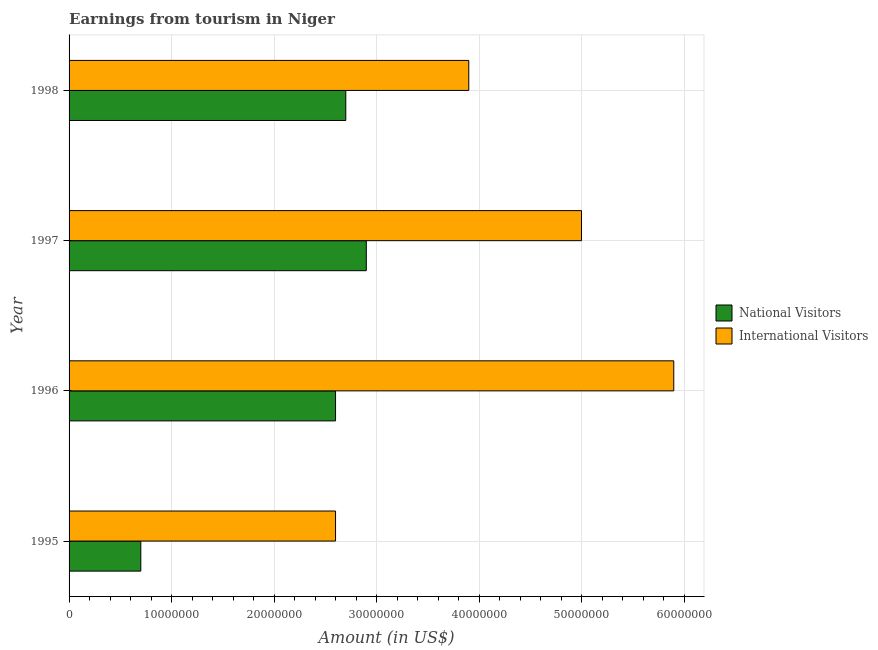How many groups of bars are there?
Give a very brief answer. 4. Are the number of bars per tick equal to the number of legend labels?
Your response must be concise. Yes. In how many cases, is the number of bars for a given year not equal to the number of legend labels?
Give a very brief answer. 0. What is the amount earned from international visitors in 1997?
Your answer should be very brief. 5.00e+07. Across all years, what is the maximum amount earned from international visitors?
Ensure brevity in your answer.  5.90e+07. Across all years, what is the minimum amount earned from national visitors?
Ensure brevity in your answer.  7.00e+06. In which year was the amount earned from national visitors maximum?
Offer a very short reply. 1997. In which year was the amount earned from international visitors minimum?
Offer a very short reply. 1995. What is the total amount earned from international visitors in the graph?
Your answer should be compact. 1.74e+08. What is the difference between the amount earned from national visitors in 1997 and that in 1998?
Provide a short and direct response. 2.00e+06. What is the difference between the amount earned from international visitors in 1995 and the amount earned from national visitors in 1998?
Your answer should be compact. -1.00e+06. What is the average amount earned from international visitors per year?
Your answer should be very brief. 4.35e+07. In the year 1995, what is the difference between the amount earned from international visitors and amount earned from national visitors?
Give a very brief answer. 1.90e+07. In how many years, is the amount earned from national visitors greater than 36000000 US$?
Your answer should be very brief. 0. What is the ratio of the amount earned from national visitors in 1995 to that in 1997?
Provide a succinct answer. 0.24. Is the difference between the amount earned from national visitors in 1996 and 1998 greater than the difference between the amount earned from international visitors in 1996 and 1998?
Offer a very short reply. No. What is the difference between the highest and the lowest amount earned from international visitors?
Your response must be concise. 3.30e+07. In how many years, is the amount earned from national visitors greater than the average amount earned from national visitors taken over all years?
Provide a short and direct response. 3. What does the 1st bar from the top in 1996 represents?
Provide a succinct answer. International Visitors. What does the 2nd bar from the bottom in 1995 represents?
Make the answer very short. International Visitors. How many bars are there?
Your answer should be very brief. 8. How many years are there in the graph?
Give a very brief answer. 4. Does the graph contain grids?
Your response must be concise. Yes. How are the legend labels stacked?
Offer a terse response. Vertical. What is the title of the graph?
Your answer should be very brief. Earnings from tourism in Niger. What is the label or title of the X-axis?
Provide a succinct answer. Amount (in US$). What is the label or title of the Y-axis?
Provide a short and direct response. Year. What is the Amount (in US$) of National Visitors in 1995?
Offer a terse response. 7.00e+06. What is the Amount (in US$) in International Visitors in 1995?
Offer a very short reply. 2.60e+07. What is the Amount (in US$) in National Visitors in 1996?
Offer a very short reply. 2.60e+07. What is the Amount (in US$) of International Visitors in 1996?
Your response must be concise. 5.90e+07. What is the Amount (in US$) in National Visitors in 1997?
Your answer should be compact. 2.90e+07. What is the Amount (in US$) in International Visitors in 1997?
Make the answer very short. 5.00e+07. What is the Amount (in US$) of National Visitors in 1998?
Offer a terse response. 2.70e+07. What is the Amount (in US$) of International Visitors in 1998?
Provide a succinct answer. 3.90e+07. Across all years, what is the maximum Amount (in US$) of National Visitors?
Offer a terse response. 2.90e+07. Across all years, what is the maximum Amount (in US$) in International Visitors?
Your answer should be very brief. 5.90e+07. Across all years, what is the minimum Amount (in US$) of International Visitors?
Provide a short and direct response. 2.60e+07. What is the total Amount (in US$) of National Visitors in the graph?
Give a very brief answer. 8.90e+07. What is the total Amount (in US$) in International Visitors in the graph?
Give a very brief answer. 1.74e+08. What is the difference between the Amount (in US$) in National Visitors in 1995 and that in 1996?
Provide a short and direct response. -1.90e+07. What is the difference between the Amount (in US$) in International Visitors in 1995 and that in 1996?
Provide a succinct answer. -3.30e+07. What is the difference between the Amount (in US$) of National Visitors in 1995 and that in 1997?
Offer a terse response. -2.20e+07. What is the difference between the Amount (in US$) in International Visitors in 1995 and that in 1997?
Your response must be concise. -2.40e+07. What is the difference between the Amount (in US$) in National Visitors in 1995 and that in 1998?
Offer a terse response. -2.00e+07. What is the difference between the Amount (in US$) in International Visitors in 1995 and that in 1998?
Your answer should be very brief. -1.30e+07. What is the difference between the Amount (in US$) of International Visitors in 1996 and that in 1997?
Your answer should be very brief. 9.00e+06. What is the difference between the Amount (in US$) in National Visitors in 1996 and that in 1998?
Provide a short and direct response. -1.00e+06. What is the difference between the Amount (in US$) in National Visitors in 1997 and that in 1998?
Provide a short and direct response. 2.00e+06. What is the difference between the Amount (in US$) in International Visitors in 1997 and that in 1998?
Offer a very short reply. 1.10e+07. What is the difference between the Amount (in US$) in National Visitors in 1995 and the Amount (in US$) in International Visitors in 1996?
Give a very brief answer. -5.20e+07. What is the difference between the Amount (in US$) in National Visitors in 1995 and the Amount (in US$) in International Visitors in 1997?
Offer a terse response. -4.30e+07. What is the difference between the Amount (in US$) of National Visitors in 1995 and the Amount (in US$) of International Visitors in 1998?
Make the answer very short. -3.20e+07. What is the difference between the Amount (in US$) in National Visitors in 1996 and the Amount (in US$) in International Visitors in 1997?
Your answer should be compact. -2.40e+07. What is the difference between the Amount (in US$) of National Visitors in 1996 and the Amount (in US$) of International Visitors in 1998?
Keep it short and to the point. -1.30e+07. What is the difference between the Amount (in US$) in National Visitors in 1997 and the Amount (in US$) in International Visitors in 1998?
Your answer should be compact. -1.00e+07. What is the average Amount (in US$) in National Visitors per year?
Provide a succinct answer. 2.22e+07. What is the average Amount (in US$) in International Visitors per year?
Keep it short and to the point. 4.35e+07. In the year 1995, what is the difference between the Amount (in US$) in National Visitors and Amount (in US$) in International Visitors?
Your answer should be very brief. -1.90e+07. In the year 1996, what is the difference between the Amount (in US$) of National Visitors and Amount (in US$) of International Visitors?
Provide a succinct answer. -3.30e+07. In the year 1997, what is the difference between the Amount (in US$) of National Visitors and Amount (in US$) of International Visitors?
Your answer should be compact. -2.10e+07. In the year 1998, what is the difference between the Amount (in US$) in National Visitors and Amount (in US$) in International Visitors?
Offer a terse response. -1.20e+07. What is the ratio of the Amount (in US$) of National Visitors in 1995 to that in 1996?
Your answer should be compact. 0.27. What is the ratio of the Amount (in US$) in International Visitors in 1995 to that in 1996?
Keep it short and to the point. 0.44. What is the ratio of the Amount (in US$) in National Visitors in 1995 to that in 1997?
Offer a terse response. 0.24. What is the ratio of the Amount (in US$) in International Visitors in 1995 to that in 1997?
Your answer should be compact. 0.52. What is the ratio of the Amount (in US$) in National Visitors in 1995 to that in 1998?
Offer a terse response. 0.26. What is the ratio of the Amount (in US$) in International Visitors in 1995 to that in 1998?
Your response must be concise. 0.67. What is the ratio of the Amount (in US$) in National Visitors in 1996 to that in 1997?
Make the answer very short. 0.9. What is the ratio of the Amount (in US$) in International Visitors in 1996 to that in 1997?
Your answer should be very brief. 1.18. What is the ratio of the Amount (in US$) in International Visitors in 1996 to that in 1998?
Offer a terse response. 1.51. What is the ratio of the Amount (in US$) in National Visitors in 1997 to that in 1998?
Provide a succinct answer. 1.07. What is the ratio of the Amount (in US$) of International Visitors in 1997 to that in 1998?
Provide a short and direct response. 1.28. What is the difference between the highest and the second highest Amount (in US$) of National Visitors?
Your answer should be very brief. 2.00e+06. What is the difference between the highest and the second highest Amount (in US$) in International Visitors?
Provide a succinct answer. 9.00e+06. What is the difference between the highest and the lowest Amount (in US$) in National Visitors?
Your response must be concise. 2.20e+07. What is the difference between the highest and the lowest Amount (in US$) of International Visitors?
Offer a terse response. 3.30e+07. 